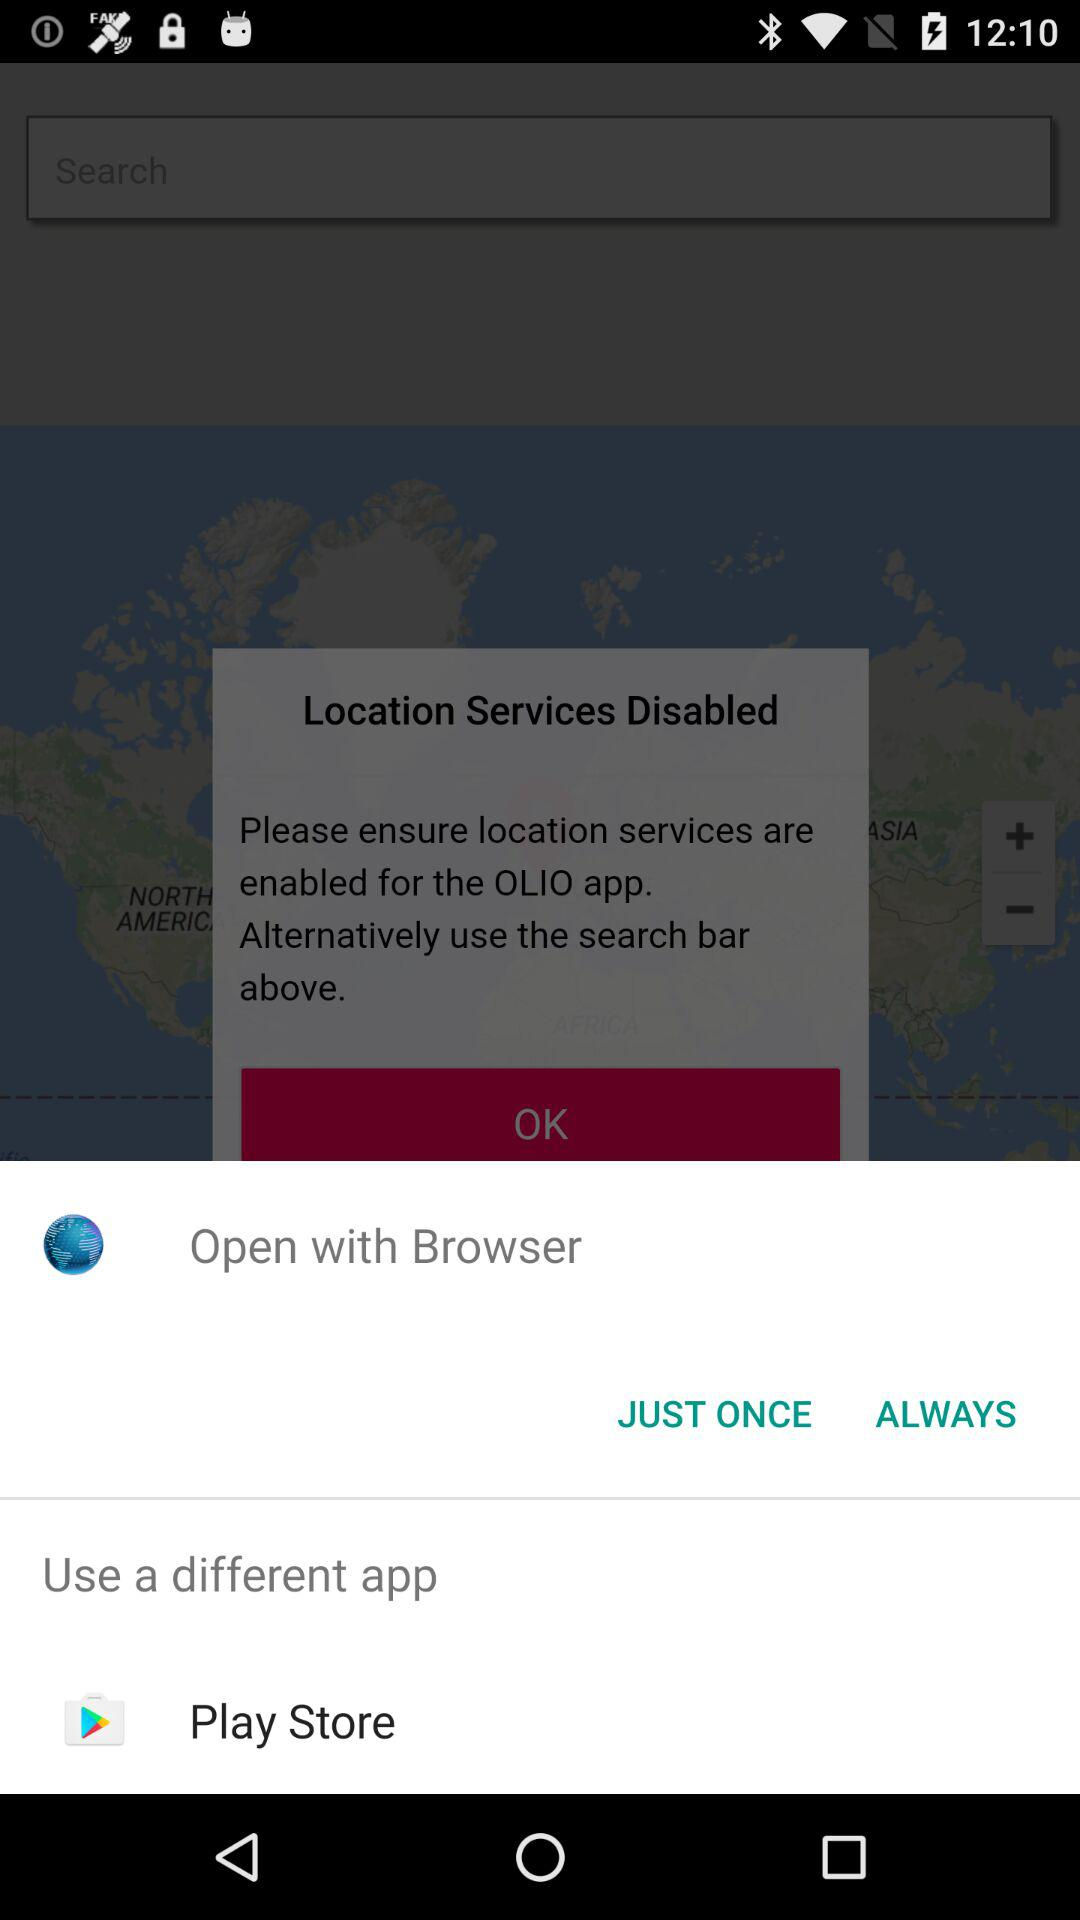Through what application can we open? We can open with "Browser" and "Play Store". 